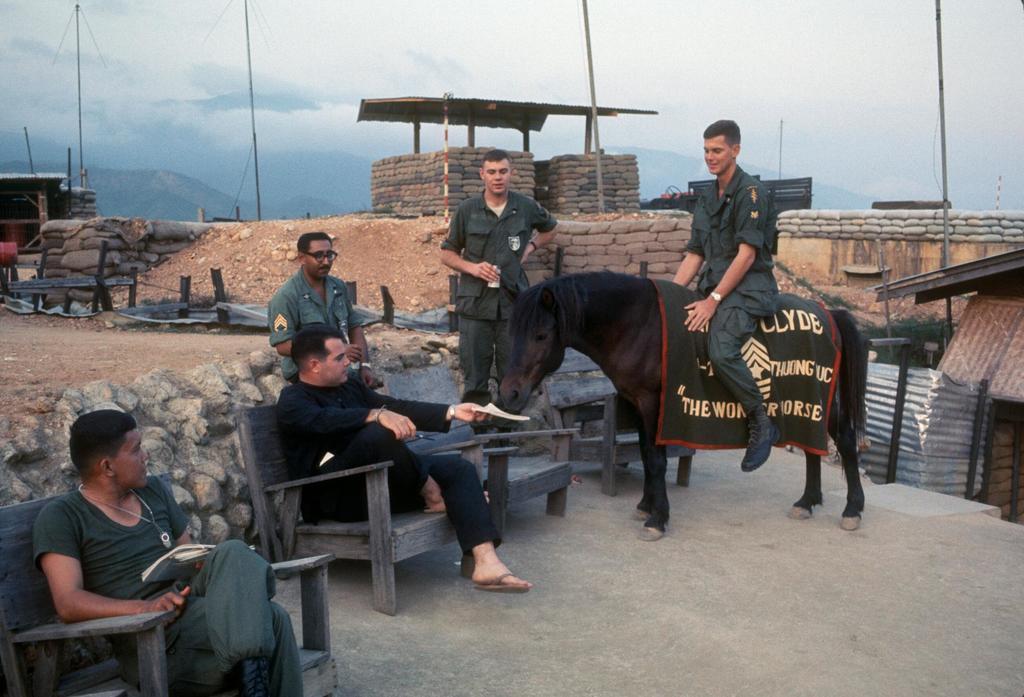Please provide a concise description of this image. Here we see a group of people were three are seated and a person is standing and other is riding a horse and we see a Blue cloudy sky. 